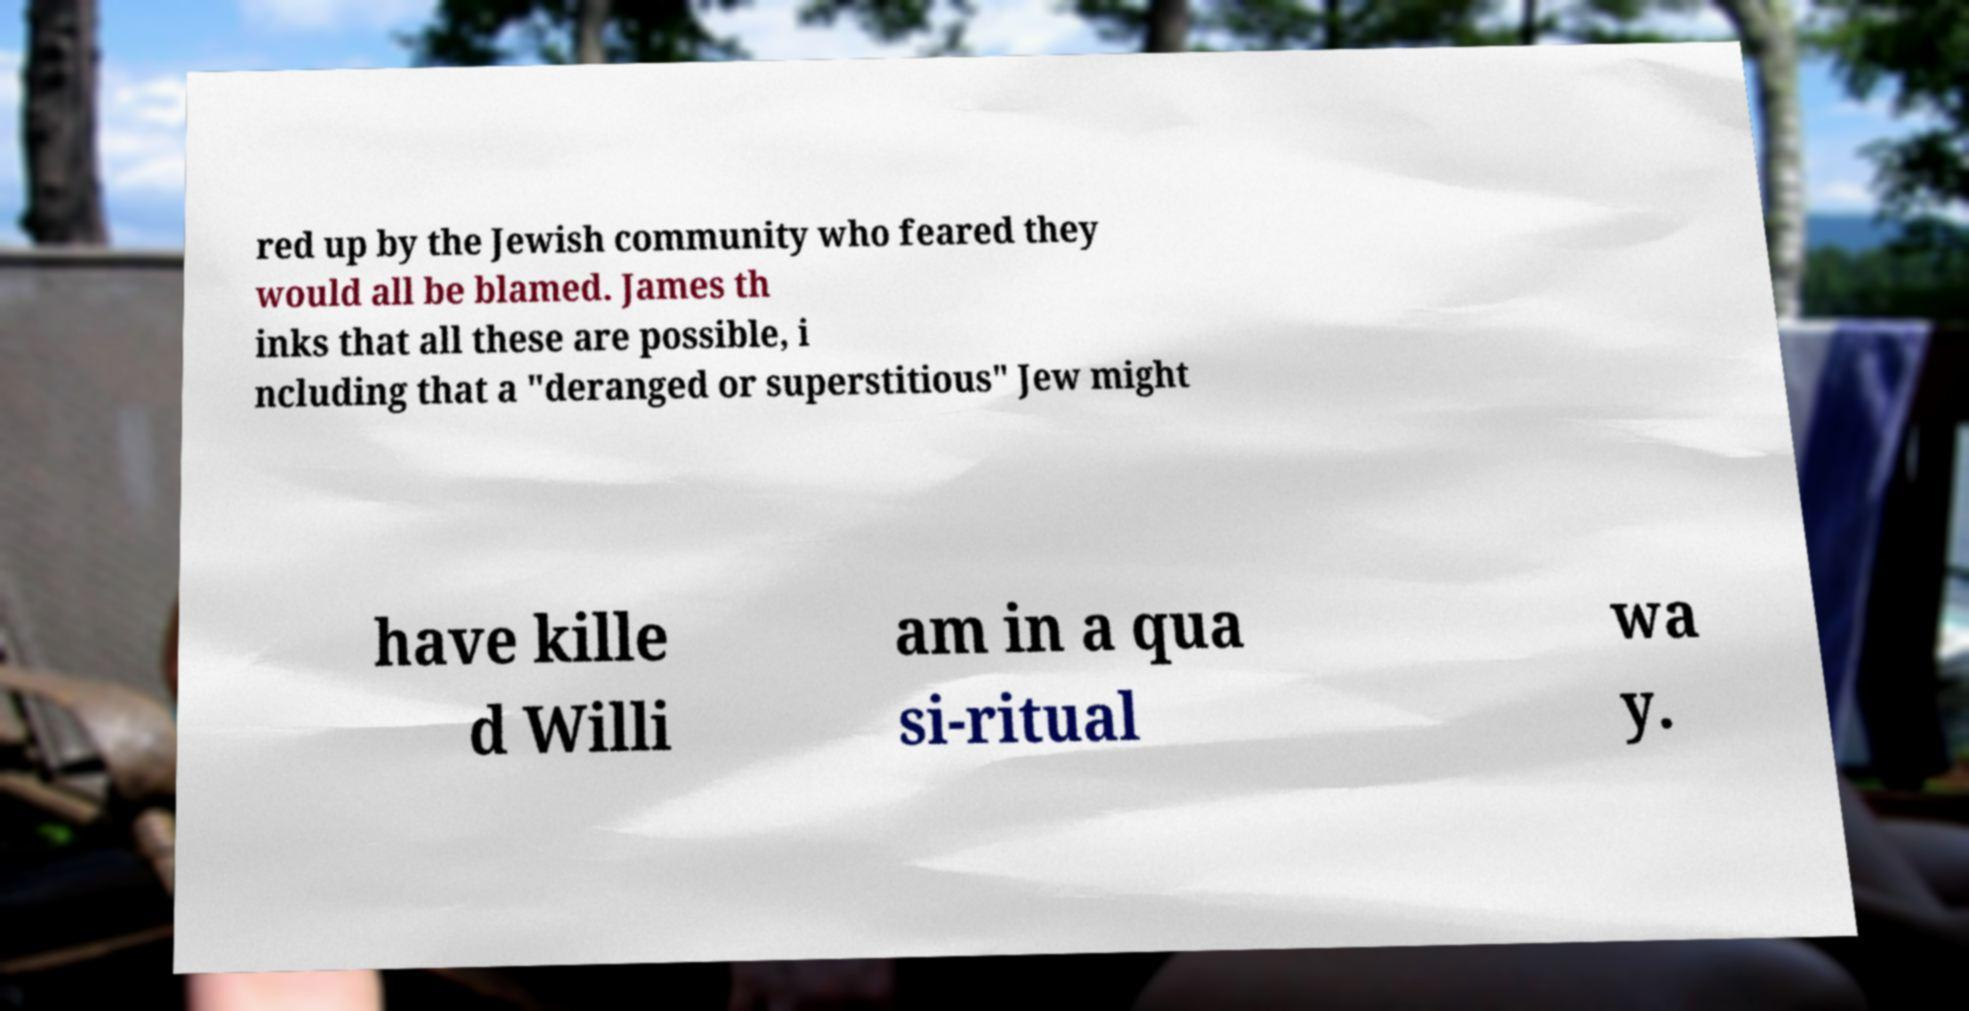Please identify and transcribe the text found in this image. red up by the Jewish community who feared they would all be blamed. James th inks that all these are possible, i ncluding that a "deranged or superstitious" Jew might have kille d Willi am in a qua si-ritual wa y. 